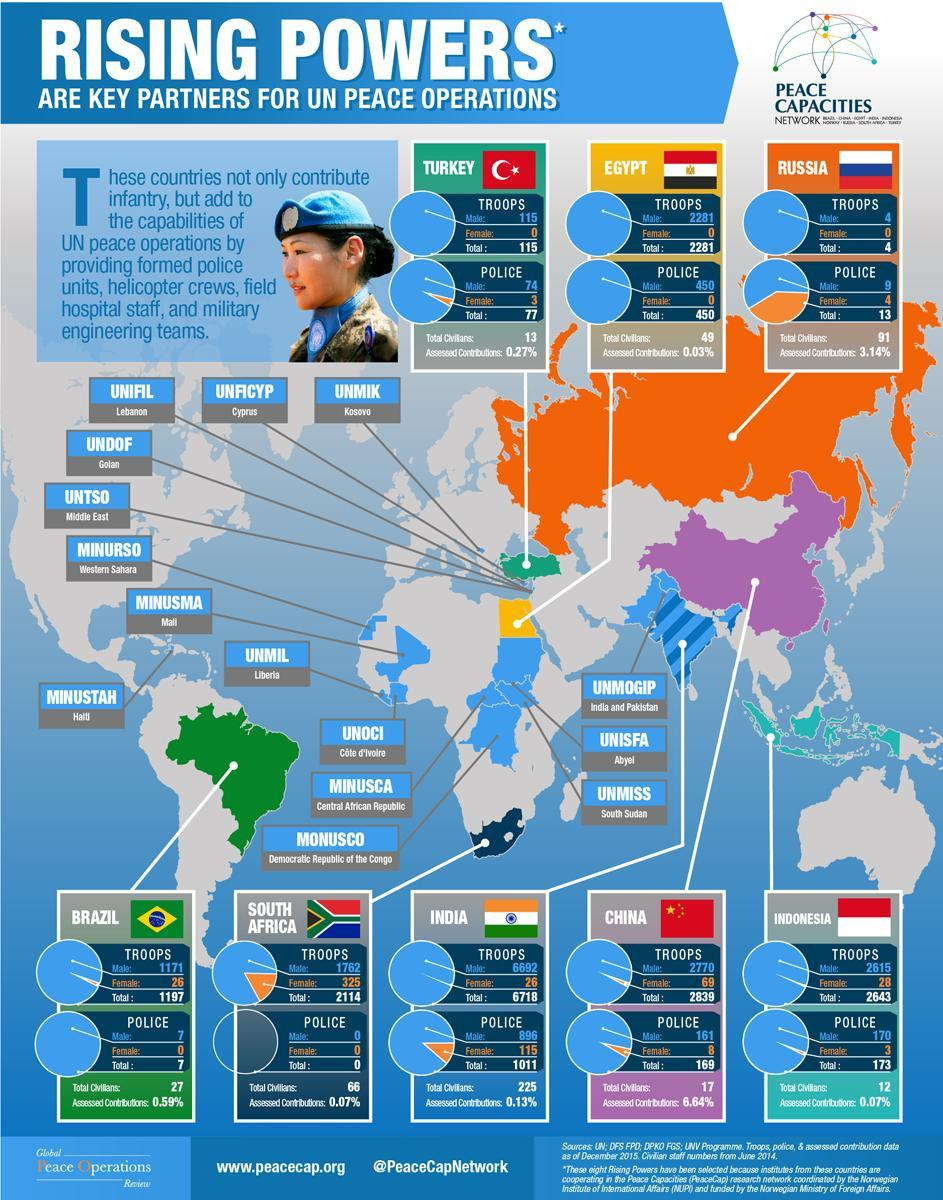Which is the United Nations military observer group in India & Pakistan?
Answer the question with a short phrase. UNMOGIP Which is the United Nations mission in Kosovo? UNMIK What percentage is the assessed contributions of Russia for UN peace operations? 3.14% How many males were present in the China troops serving the UN peace operations? 2770 What percentage is the assessed contributions of India for UN peace operations? 0.13% What percentage is the assessed contributions of Indonesia for UN peace operations? 0.07% Which is the United Nations mission in South Sudan? UNMISS What is the total number of troops from Egypt serving the UN peace operations? 2281 What is the total number of police force from brazil serving the UN peace operations? 7 How many females are present in the Indian troops serving the UN peace operations? 26 